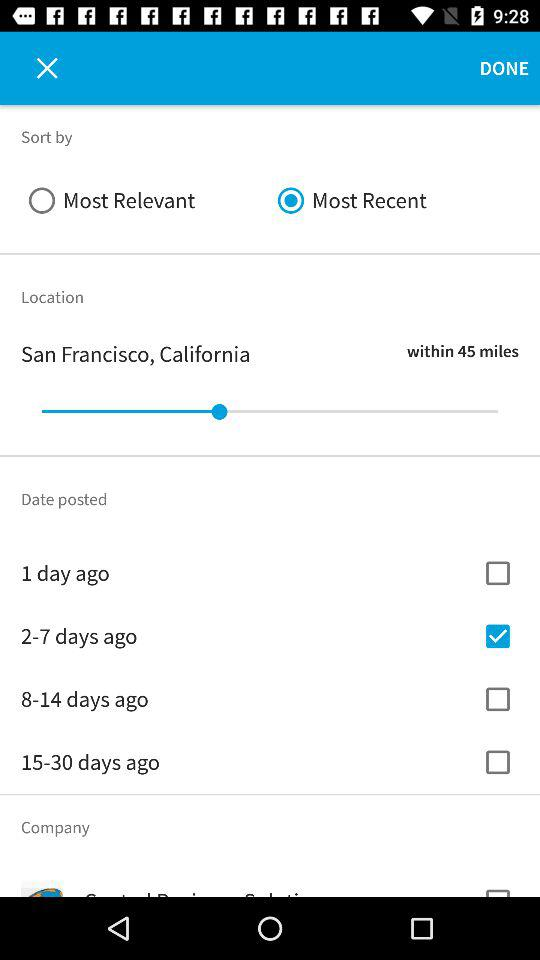What is the selected checkbox? The selected checkbox is "2-7 days ago". 